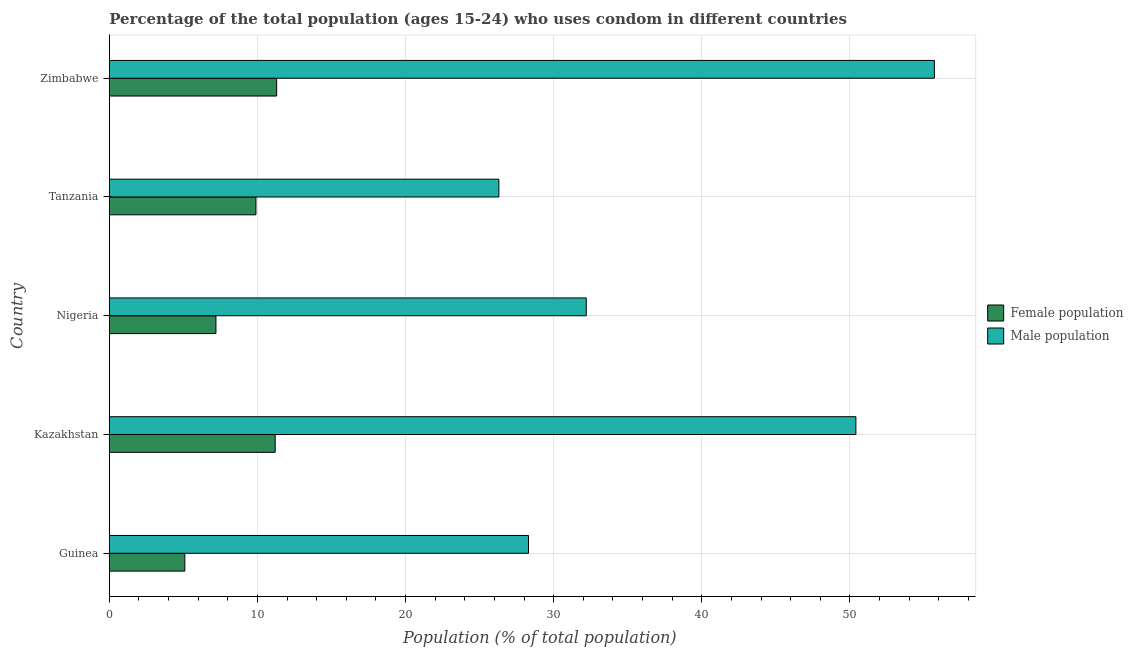How many groups of bars are there?
Ensure brevity in your answer.  5. What is the label of the 3rd group of bars from the top?
Your answer should be compact. Nigeria. Across all countries, what is the maximum male population?
Keep it short and to the point. 55.7. Across all countries, what is the minimum male population?
Offer a terse response. 26.3. In which country was the male population maximum?
Keep it short and to the point. Zimbabwe. In which country was the female population minimum?
Your response must be concise. Guinea. What is the total female population in the graph?
Ensure brevity in your answer.  44.7. What is the difference between the male population in Tanzania and the female population in Zimbabwe?
Offer a very short reply. 15. What is the average female population per country?
Your response must be concise. 8.94. What is the difference between the male population and female population in Zimbabwe?
Provide a short and direct response. 44.4. In how many countries, is the female population greater than 4 %?
Your answer should be compact. 5. What is the ratio of the male population in Tanzania to that in Zimbabwe?
Provide a short and direct response. 0.47. Is the difference between the female population in Nigeria and Tanzania greater than the difference between the male population in Nigeria and Tanzania?
Keep it short and to the point. No. What is the difference between the highest and the second highest male population?
Your answer should be very brief. 5.3. Is the sum of the female population in Kazakhstan and Tanzania greater than the maximum male population across all countries?
Make the answer very short. No. What does the 1st bar from the top in Guinea represents?
Your response must be concise. Male population. What does the 1st bar from the bottom in Nigeria represents?
Your response must be concise. Female population. How many bars are there?
Your response must be concise. 10. What is the difference between two consecutive major ticks on the X-axis?
Your response must be concise. 10. Are the values on the major ticks of X-axis written in scientific E-notation?
Provide a short and direct response. No. Does the graph contain any zero values?
Your response must be concise. No. Does the graph contain grids?
Your answer should be very brief. Yes. How many legend labels are there?
Your response must be concise. 2. What is the title of the graph?
Make the answer very short. Percentage of the total population (ages 15-24) who uses condom in different countries. Does "Under five" appear as one of the legend labels in the graph?
Provide a succinct answer. No. What is the label or title of the X-axis?
Offer a terse response. Population (% of total population) . What is the Population (% of total population)  in Female population in Guinea?
Give a very brief answer. 5.1. What is the Population (% of total population)  in Male population in Guinea?
Give a very brief answer. 28.3. What is the Population (% of total population)  in Male population in Kazakhstan?
Ensure brevity in your answer.  50.4. What is the Population (% of total population)  of Female population in Nigeria?
Make the answer very short. 7.2. What is the Population (% of total population)  in Male population in Nigeria?
Your answer should be very brief. 32.2. What is the Population (% of total population)  of Female population in Tanzania?
Offer a very short reply. 9.9. What is the Population (% of total population)  in Male population in Tanzania?
Your answer should be compact. 26.3. What is the Population (% of total population)  of Female population in Zimbabwe?
Offer a very short reply. 11.3. What is the Population (% of total population)  of Male population in Zimbabwe?
Ensure brevity in your answer.  55.7. Across all countries, what is the maximum Population (% of total population)  of Male population?
Keep it short and to the point. 55.7. Across all countries, what is the minimum Population (% of total population)  in Male population?
Offer a very short reply. 26.3. What is the total Population (% of total population)  of Female population in the graph?
Provide a short and direct response. 44.7. What is the total Population (% of total population)  in Male population in the graph?
Offer a terse response. 192.9. What is the difference between the Population (% of total population)  in Female population in Guinea and that in Kazakhstan?
Provide a succinct answer. -6.1. What is the difference between the Population (% of total population)  of Male population in Guinea and that in Kazakhstan?
Provide a succinct answer. -22.1. What is the difference between the Population (% of total population)  in Male population in Guinea and that in Nigeria?
Provide a short and direct response. -3.9. What is the difference between the Population (% of total population)  of Female population in Guinea and that in Zimbabwe?
Make the answer very short. -6.2. What is the difference between the Population (% of total population)  in Male population in Guinea and that in Zimbabwe?
Your answer should be very brief. -27.4. What is the difference between the Population (% of total population)  of Male population in Kazakhstan and that in Tanzania?
Your answer should be compact. 24.1. What is the difference between the Population (% of total population)  of Female population in Nigeria and that in Tanzania?
Your response must be concise. -2.7. What is the difference between the Population (% of total population)  of Male population in Nigeria and that in Zimbabwe?
Your answer should be very brief. -23.5. What is the difference between the Population (% of total population)  of Female population in Tanzania and that in Zimbabwe?
Make the answer very short. -1.4. What is the difference between the Population (% of total population)  in Male population in Tanzania and that in Zimbabwe?
Give a very brief answer. -29.4. What is the difference between the Population (% of total population)  of Female population in Guinea and the Population (% of total population)  of Male population in Kazakhstan?
Ensure brevity in your answer.  -45.3. What is the difference between the Population (% of total population)  in Female population in Guinea and the Population (% of total population)  in Male population in Nigeria?
Your response must be concise. -27.1. What is the difference between the Population (% of total population)  of Female population in Guinea and the Population (% of total population)  of Male population in Tanzania?
Offer a very short reply. -21.2. What is the difference between the Population (% of total population)  in Female population in Guinea and the Population (% of total population)  in Male population in Zimbabwe?
Your answer should be very brief. -50.6. What is the difference between the Population (% of total population)  of Female population in Kazakhstan and the Population (% of total population)  of Male population in Tanzania?
Keep it short and to the point. -15.1. What is the difference between the Population (% of total population)  in Female population in Kazakhstan and the Population (% of total population)  in Male population in Zimbabwe?
Offer a very short reply. -44.5. What is the difference between the Population (% of total population)  in Female population in Nigeria and the Population (% of total population)  in Male population in Tanzania?
Provide a succinct answer. -19.1. What is the difference between the Population (% of total population)  in Female population in Nigeria and the Population (% of total population)  in Male population in Zimbabwe?
Your answer should be very brief. -48.5. What is the difference between the Population (% of total population)  in Female population in Tanzania and the Population (% of total population)  in Male population in Zimbabwe?
Give a very brief answer. -45.8. What is the average Population (% of total population)  in Female population per country?
Offer a terse response. 8.94. What is the average Population (% of total population)  of Male population per country?
Offer a terse response. 38.58. What is the difference between the Population (% of total population)  of Female population and Population (% of total population)  of Male population in Guinea?
Your answer should be very brief. -23.2. What is the difference between the Population (% of total population)  of Female population and Population (% of total population)  of Male population in Kazakhstan?
Give a very brief answer. -39.2. What is the difference between the Population (% of total population)  in Female population and Population (% of total population)  in Male population in Tanzania?
Your answer should be compact. -16.4. What is the difference between the Population (% of total population)  of Female population and Population (% of total population)  of Male population in Zimbabwe?
Your answer should be compact. -44.4. What is the ratio of the Population (% of total population)  of Female population in Guinea to that in Kazakhstan?
Offer a terse response. 0.46. What is the ratio of the Population (% of total population)  in Male population in Guinea to that in Kazakhstan?
Make the answer very short. 0.56. What is the ratio of the Population (% of total population)  in Female population in Guinea to that in Nigeria?
Provide a short and direct response. 0.71. What is the ratio of the Population (% of total population)  in Male population in Guinea to that in Nigeria?
Make the answer very short. 0.88. What is the ratio of the Population (% of total population)  of Female population in Guinea to that in Tanzania?
Ensure brevity in your answer.  0.52. What is the ratio of the Population (% of total population)  in Male population in Guinea to that in Tanzania?
Offer a very short reply. 1.08. What is the ratio of the Population (% of total population)  of Female population in Guinea to that in Zimbabwe?
Make the answer very short. 0.45. What is the ratio of the Population (% of total population)  of Male population in Guinea to that in Zimbabwe?
Your answer should be compact. 0.51. What is the ratio of the Population (% of total population)  of Female population in Kazakhstan to that in Nigeria?
Offer a terse response. 1.56. What is the ratio of the Population (% of total population)  in Male population in Kazakhstan to that in Nigeria?
Your response must be concise. 1.57. What is the ratio of the Population (% of total population)  in Female population in Kazakhstan to that in Tanzania?
Offer a very short reply. 1.13. What is the ratio of the Population (% of total population)  of Male population in Kazakhstan to that in Tanzania?
Offer a terse response. 1.92. What is the ratio of the Population (% of total population)  of Female population in Kazakhstan to that in Zimbabwe?
Your answer should be compact. 0.99. What is the ratio of the Population (% of total population)  of Male population in Kazakhstan to that in Zimbabwe?
Provide a short and direct response. 0.9. What is the ratio of the Population (% of total population)  in Female population in Nigeria to that in Tanzania?
Ensure brevity in your answer.  0.73. What is the ratio of the Population (% of total population)  in Male population in Nigeria to that in Tanzania?
Provide a succinct answer. 1.22. What is the ratio of the Population (% of total population)  in Female population in Nigeria to that in Zimbabwe?
Your response must be concise. 0.64. What is the ratio of the Population (% of total population)  of Male population in Nigeria to that in Zimbabwe?
Offer a terse response. 0.58. What is the ratio of the Population (% of total population)  of Female population in Tanzania to that in Zimbabwe?
Offer a terse response. 0.88. What is the ratio of the Population (% of total population)  of Male population in Tanzania to that in Zimbabwe?
Provide a succinct answer. 0.47. What is the difference between the highest and the second highest Population (% of total population)  in Female population?
Offer a terse response. 0.1. What is the difference between the highest and the lowest Population (% of total population)  in Female population?
Keep it short and to the point. 6.2. What is the difference between the highest and the lowest Population (% of total population)  in Male population?
Keep it short and to the point. 29.4. 